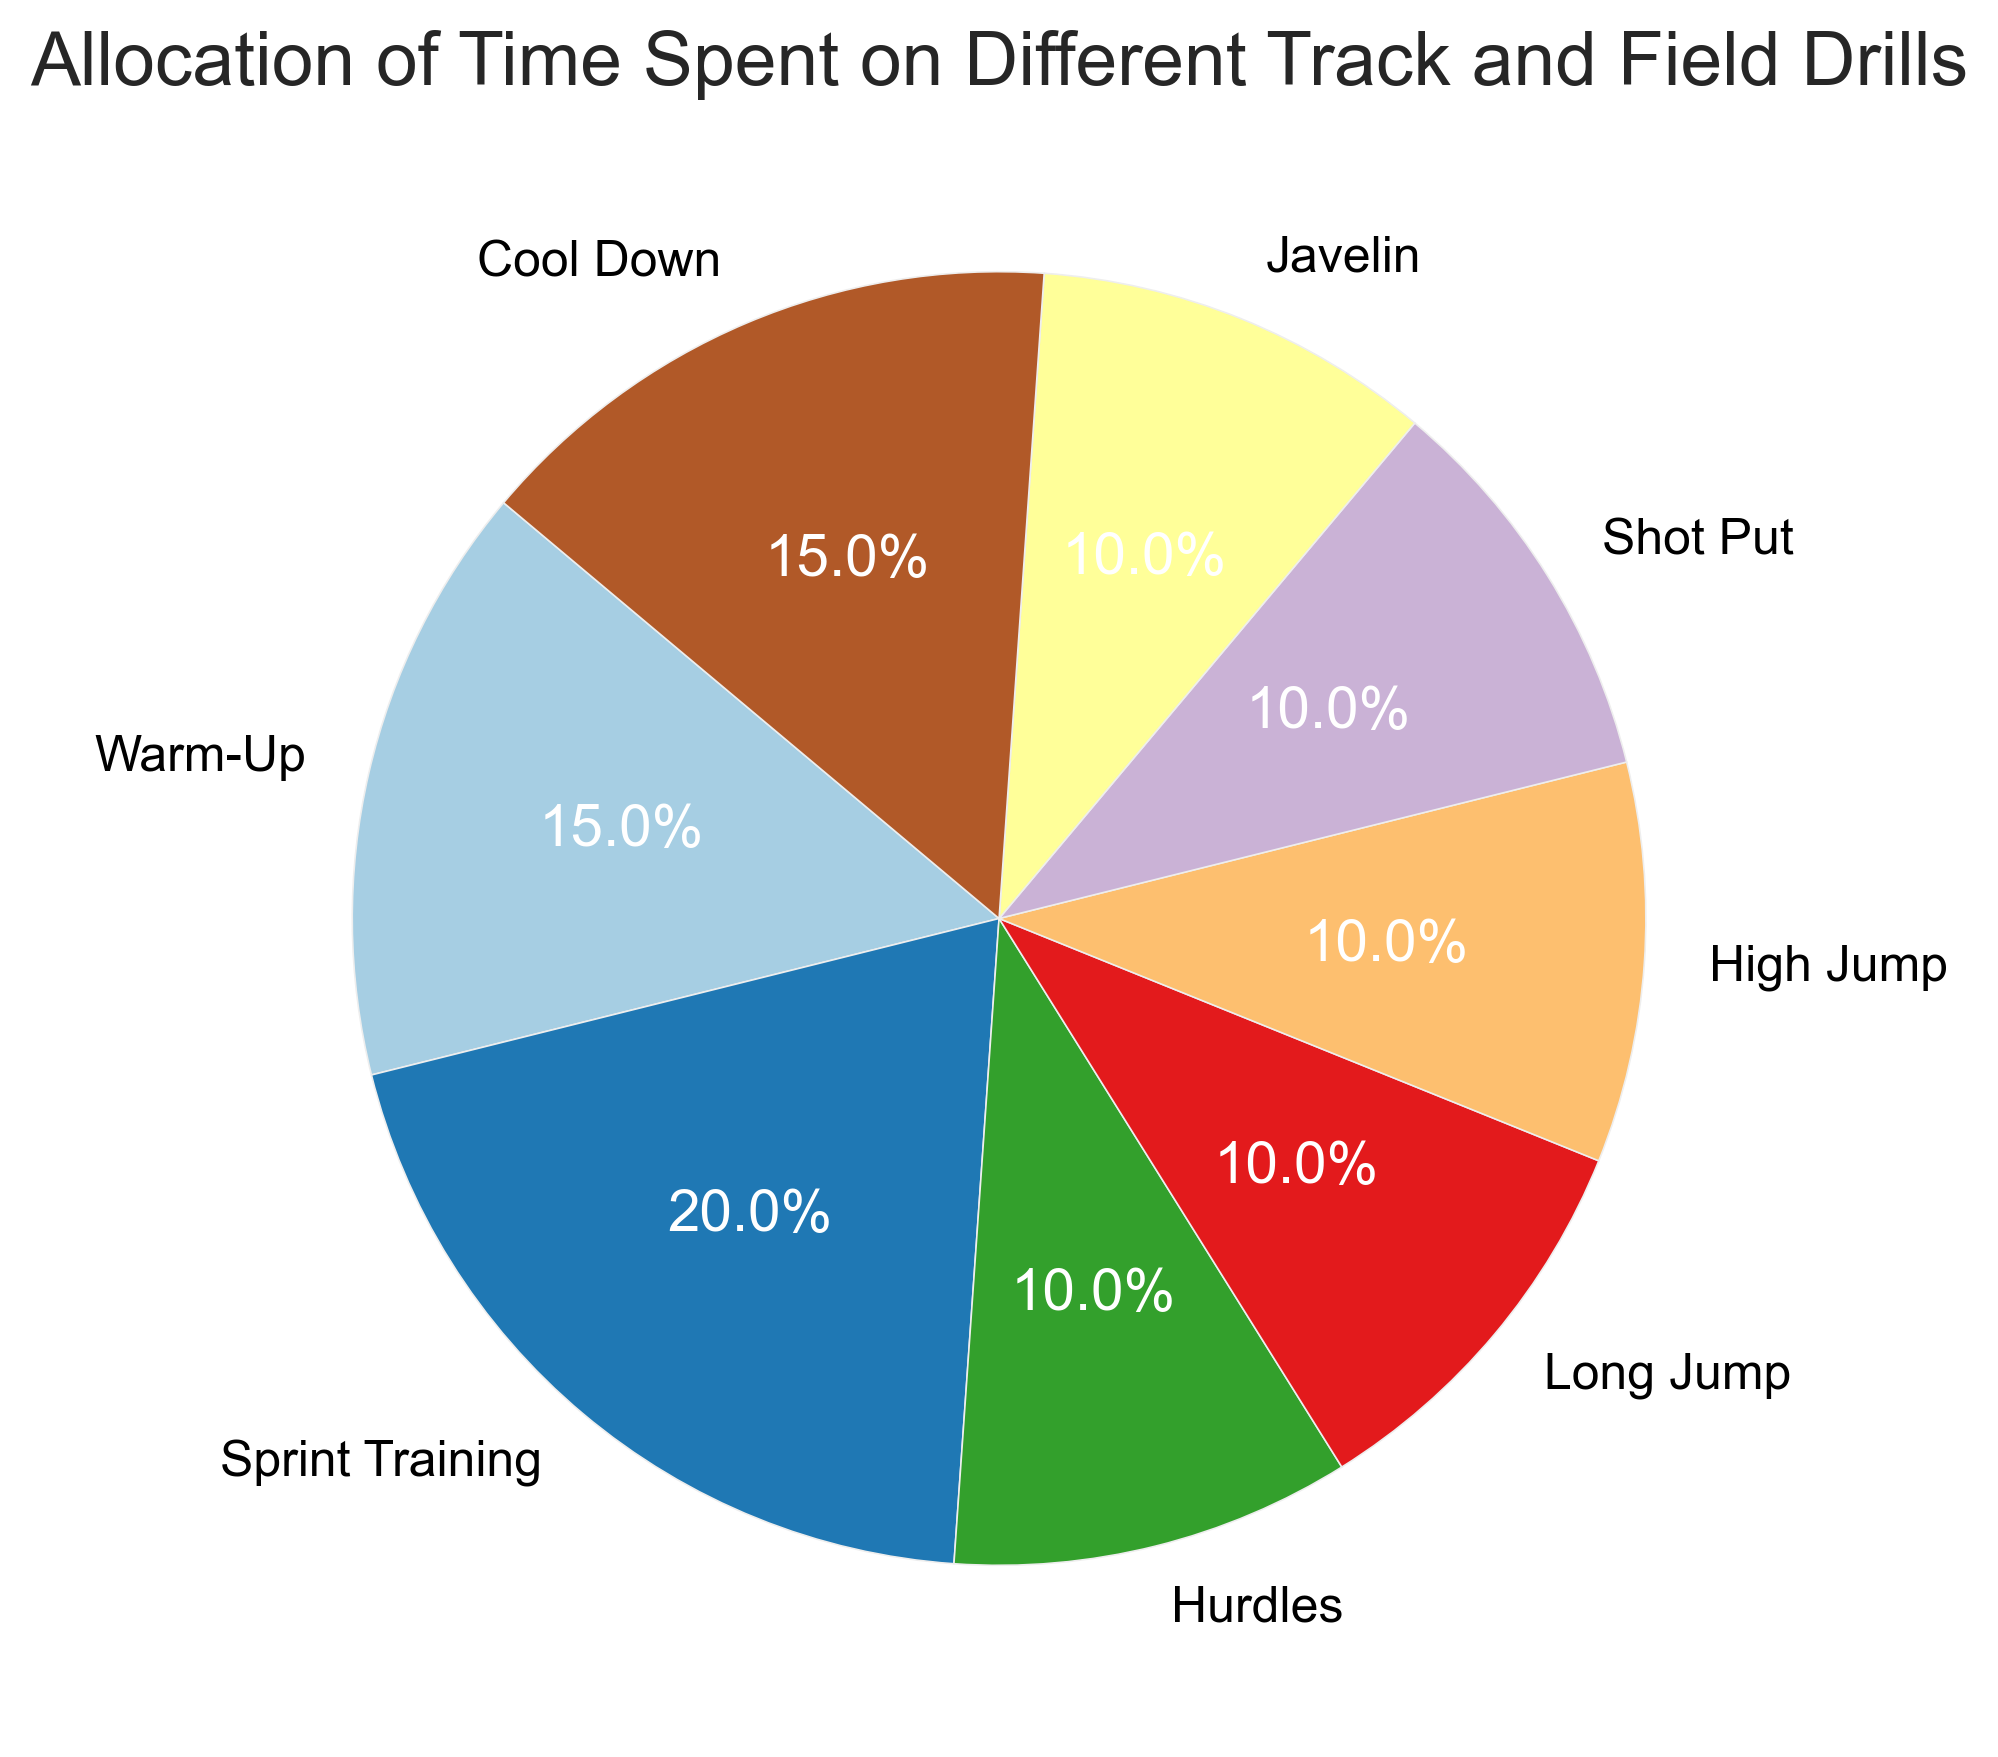What's the total percentage of time spent on field events (Long Jump, High Jump, Shot Put, Javelin)? Add the percentages for Long Jump (10%), High Jump (10%), Shot Put (10%), and Javelin (10%). 10% + 10% + 10% + 10% = 40%.
Answer: 40% Which drill takes up more time, Sprint Training or Warm-Up? Sprint Training takes up 20% of the time while Warm-Up takes up 15% of the time. Therefore, Sprint Training takes up more time.
Answer: Sprint Training Are Warm-Up and Cool Down drills allocated equal amounts of time? According to the pie chart, both Warm-Up and Cool Down drills each take up 15% of the time. Hence they are allocated equal amounts of time.
Answer: Yes What is the sum of the percentages for Hurdles, Long Jump, and High Jump? Hurdles (10%) + Long Jump (10%) + High Jump (10%) = 10% + 10% + 10% = 30%.
Answer: 30% How does the percentage of time for Hurdles compare to that for Shot Put? Both Hurdles and Shot Put take up 10% of the time each. Therefore, the percentages are equal.
Answer: Equal Which two drills have the same allocation of time as Sprint Training collectively? Warm-Up (15%) + Cool Down (15%) = 30%. Sprint Training takes up 20%. None of the two drill combinations equal 20%, but they individually align with other combinations.
Answer: None Is more time spent on Sprint Training than on Javelin and Shot Put combined? Sprint Training has 20% while Javelin and Shot Put each have 10%. Combined, Javelin and Shot Put take up 10% + 10% = 20%, which is equal to the time spent on Sprint Training.
Answer: Equal Identify the drills with the smallest allocation of time. The smallest percentage allocated to any drills are Hurdles, Long Jump, High Jump, Shot Put, and Javelin, each at 10%.
Answer: Hurdles, Long Jump, High Jump, Shot Put, Javelin How much more time is allocated to Sprint Training compared to Hurdles? Sprint Training is allocated 20% of the time, and Hurdles is allocated 10% of the time. The difference is 20% - 10% = 10%.
Answer: 10% 